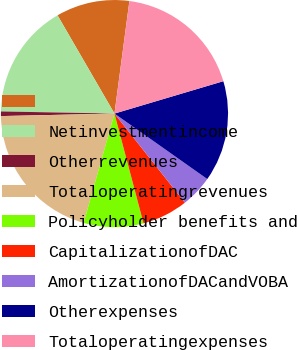Convert chart to OTSL. <chart><loc_0><loc_0><loc_500><loc_500><pie_chart><ecel><fcel>Netinvestmentincome<fcel>Otherrevenues<fcel>Totaloperatingrevenues<fcel>Policyholder benefits and<fcel>CapitalizationofDAC<fcel>AmortizationofDACandVOBA<fcel>Otherexpenses<fcel>Totaloperatingexpenses<nl><fcel>10.46%<fcel>16.34%<fcel>0.65%<fcel>20.27%<fcel>8.5%<fcel>6.53%<fcel>4.57%<fcel>14.38%<fcel>18.3%<nl></chart> 